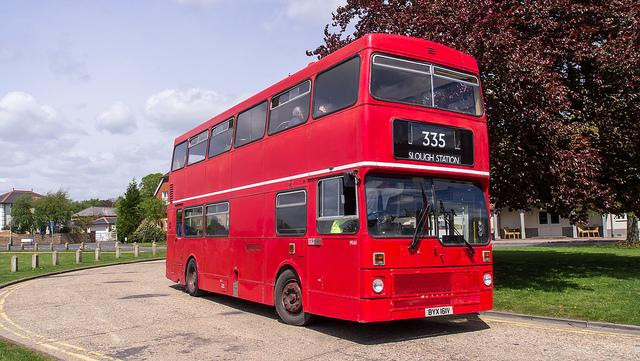One can board a train in which region after they disembark from this bus? Please explain your reasoning. western. These double-decker buses are found in this main uk city. 